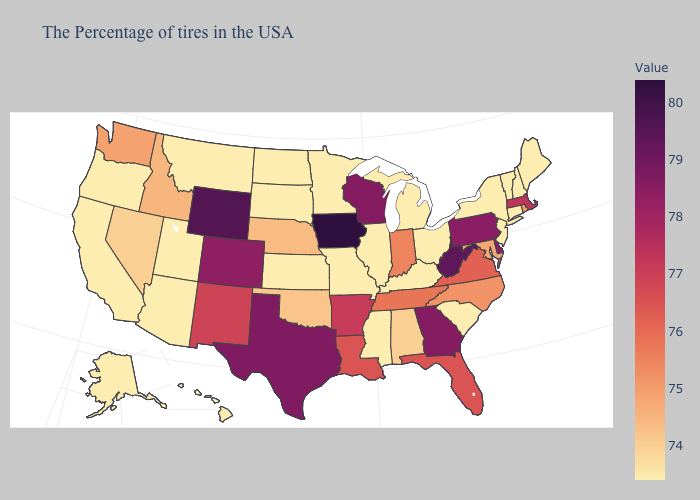Which states have the lowest value in the USA?
Write a very short answer. Maine, New Hampshire, Vermont, Connecticut, New York, New Jersey, South Carolina, Ohio, Michigan, Kentucky, Illinois, Mississippi, Missouri, Minnesota, Kansas, South Dakota, North Dakota, Utah, Montana, Arizona, California, Oregon, Alaska, Hawaii. Which states hav the highest value in the South?
Quick response, please. West Virginia. Among the states that border Michigan , does Wisconsin have the lowest value?
Be succinct. No. Does Alabama have a higher value than Maryland?
Concise answer only. No. Does New Hampshire have the highest value in the USA?
Answer briefly. No. Among the states that border Oklahoma , which have the lowest value?
Be succinct. Missouri, Kansas. 